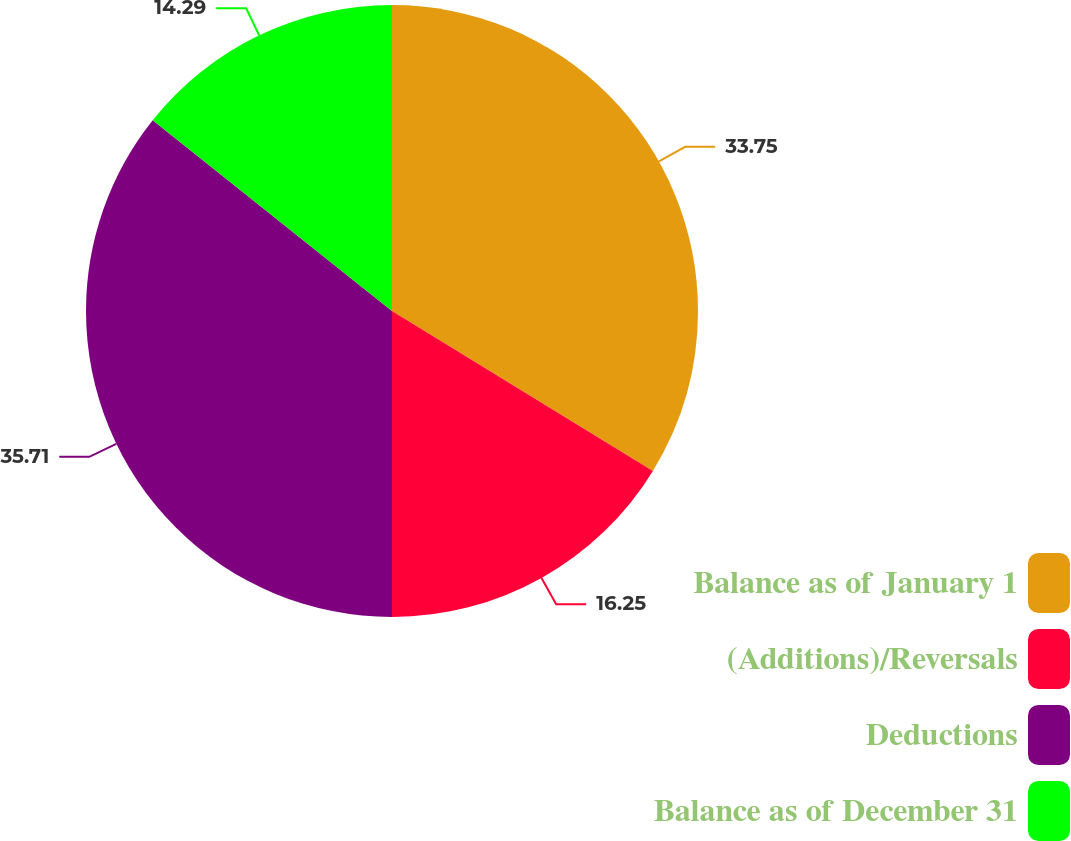<chart> <loc_0><loc_0><loc_500><loc_500><pie_chart><fcel>Balance as of January 1<fcel>(Additions)/Reversals<fcel>Deductions<fcel>Balance as of December 31<nl><fcel>33.75%<fcel>16.25%<fcel>35.71%<fcel>14.29%<nl></chart> 